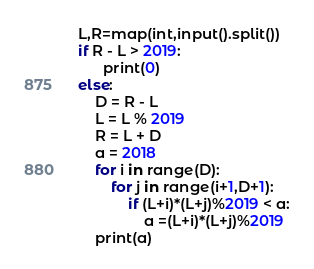Convert code to text. <code><loc_0><loc_0><loc_500><loc_500><_Python_>L,R=map(int,input().split())
if R - L > 2019:
      print(0)
else:
    D = R - L
    L = L % 2019
    R = L + D
    a = 2018
    for i in range(D):
        for j in range(i+1,D+1):
            if (L+i)*(L+j)%2019 < a:
                a =(L+i)*(L+j)%2019
    print(a)
</code> 